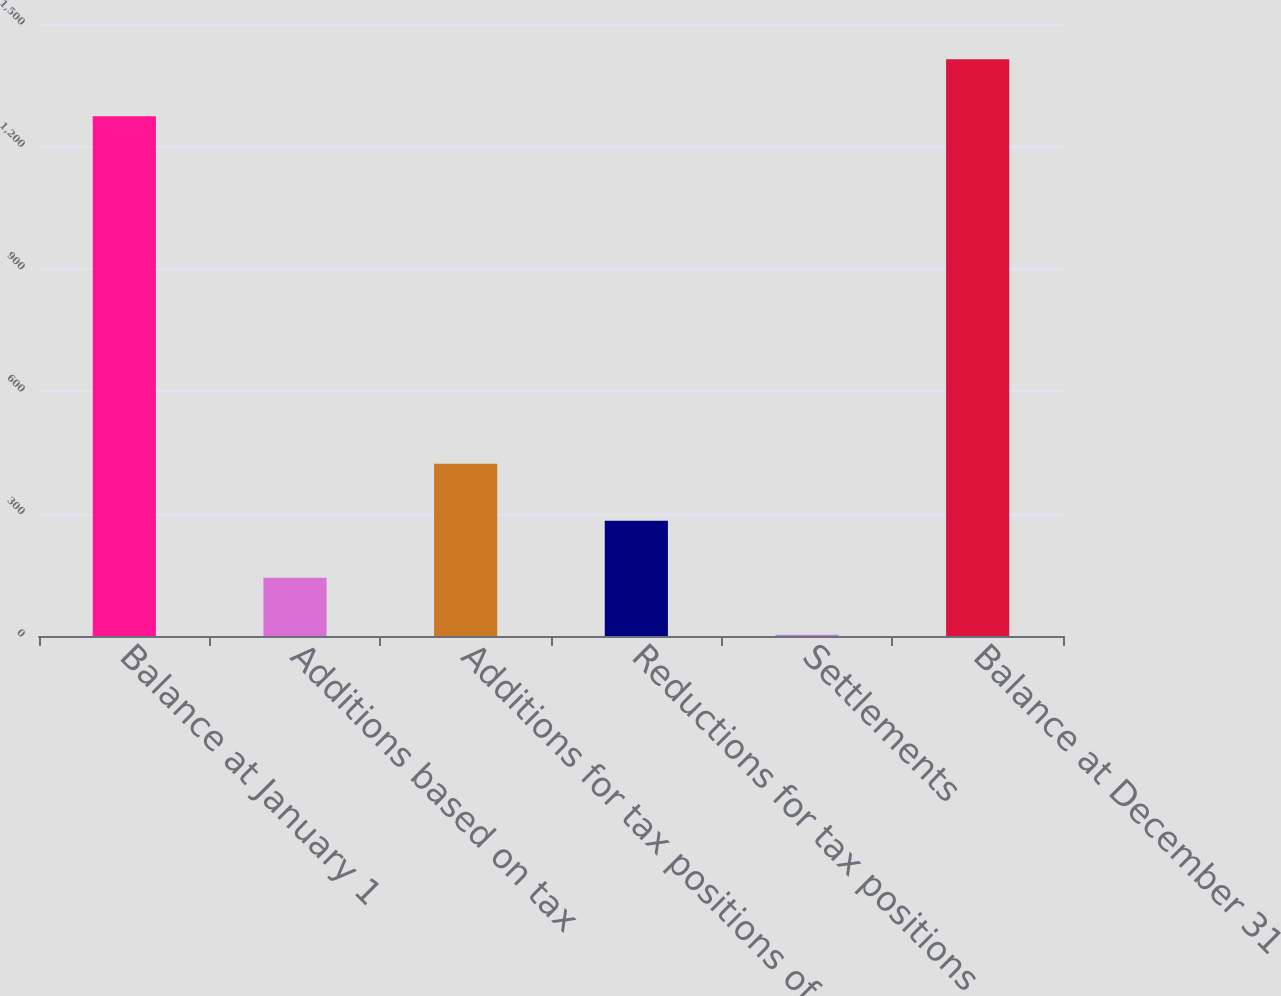<chart> <loc_0><loc_0><loc_500><loc_500><bar_chart><fcel>Balance at January 1<fcel>Additions based on tax<fcel>Additions for tax positions of<fcel>Reductions for tax positions<fcel>Settlements<fcel>Balance at December 31<nl><fcel>1274<fcel>142.7<fcel>422.1<fcel>282.4<fcel>3<fcel>1413.7<nl></chart> 